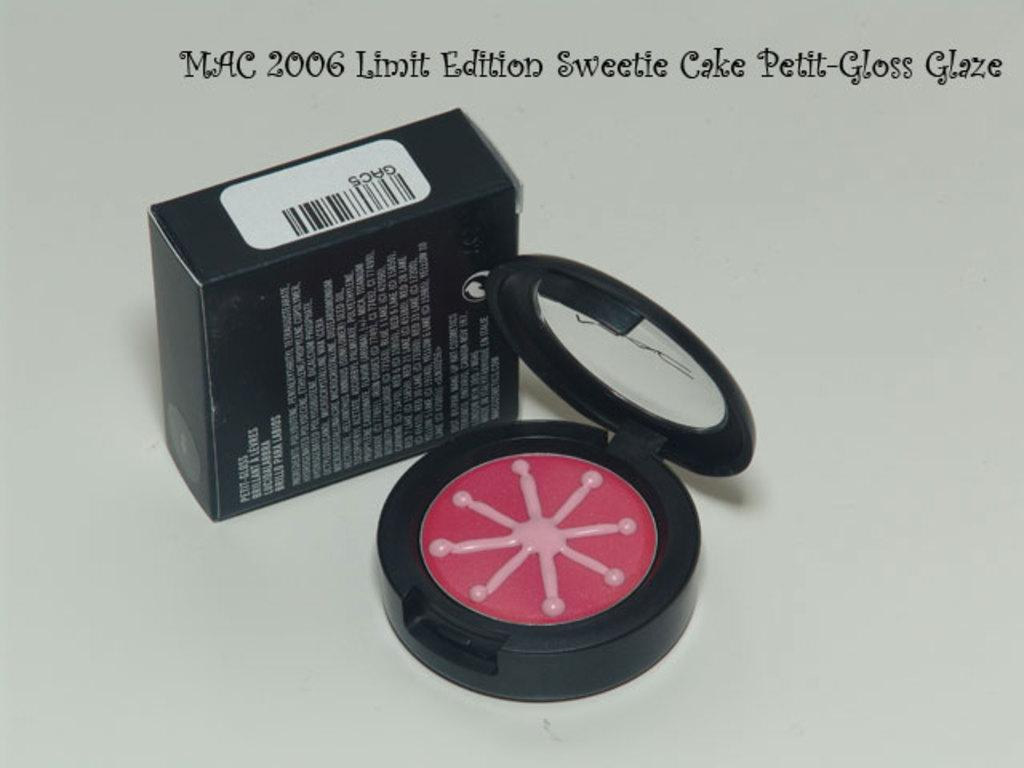<image>
Render a clear and concise summary of the photo. The gloss shown here is the MAC limited edition sweetie cake gloss 